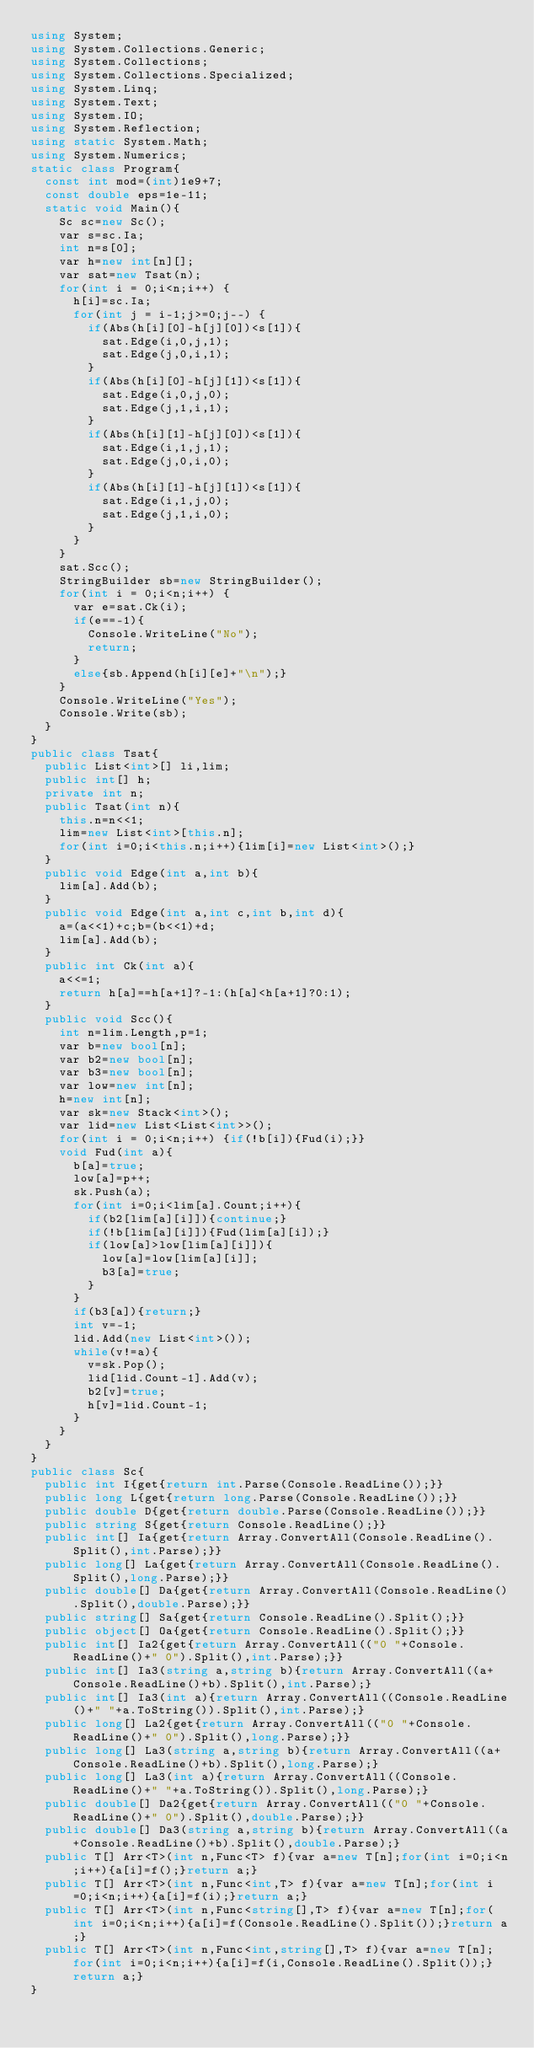Convert code to text. <code><loc_0><loc_0><loc_500><loc_500><_C#_>using System;
using System.Collections.Generic;
using System.Collections;
using System.Collections.Specialized;
using System.Linq;
using System.Text;
using System.IO;
using System.Reflection;
using static System.Math;
using System.Numerics;
static class Program{
	const int mod=(int)1e9+7;
	const double eps=1e-11;
	static void Main(){
		Sc sc=new Sc();
		var s=sc.Ia;
		int n=s[0];
		var h=new int[n][];
		var sat=new Tsat(n);
		for(int i = 0;i<n;i++) {
			h[i]=sc.Ia;
			for(int j = i-1;j>=0;j--) {
				if(Abs(h[i][0]-h[j][0])<s[1]){
					sat.Edge(i,0,j,1);
					sat.Edge(j,0,i,1);
				}
				if(Abs(h[i][0]-h[j][1])<s[1]){
					sat.Edge(i,0,j,0);
					sat.Edge(j,1,i,1);
				}
				if(Abs(h[i][1]-h[j][0])<s[1]){
					sat.Edge(i,1,j,1);
					sat.Edge(j,0,i,0);
				}
				if(Abs(h[i][1]-h[j][1])<s[1]){
					sat.Edge(i,1,j,0);
					sat.Edge(j,1,i,0);
				}
			}
		}
		sat.Scc();
		StringBuilder sb=new StringBuilder();
		for(int i = 0;i<n;i++) {
			var e=sat.Ck(i);
			if(e==-1){
				Console.WriteLine("No");
				return;
			}
			else{sb.Append(h[i][e]+"\n");}
		}
		Console.WriteLine("Yes");
		Console.Write(sb);
	}
}
public class Tsat{
	public List<int>[] li,lim;
	public int[] h;
	private int n;
	public Tsat(int n){
		this.n=n<<1;
		lim=new List<int>[this.n];
		for(int i=0;i<this.n;i++){lim[i]=new List<int>();}
	}
	public void Edge(int a,int b){
		lim[a].Add(b);
	}
	public void Edge(int a,int c,int b,int d){
		a=(a<<1)+c;b=(b<<1)+d;
		lim[a].Add(b);
	}
	public int Ck(int a){
		a<<=1;
		return h[a]==h[a+1]?-1:(h[a]<h[a+1]?0:1);
	}
	public void Scc(){
		int n=lim.Length,p=1;
		var b=new bool[n];
		var b2=new bool[n];
		var b3=new bool[n];
		var low=new int[n];
		h=new int[n];
		var sk=new Stack<int>();
		var lid=new List<List<int>>();
		for(int i = 0;i<n;i++) {if(!b[i]){Fud(i);}}
		void Fud(int a){
			b[a]=true;
			low[a]=p++;
			sk.Push(a);
			for(int i=0;i<lim[a].Count;i++){
				if(b2[lim[a][i]]){continue;}
				if(!b[lim[a][i]]){Fud(lim[a][i]);}
				if(low[a]>low[lim[a][i]]){
					low[a]=low[lim[a][i]];
					b3[a]=true;
				}
			}
			if(b3[a]){return;}
			int v=-1;
			lid.Add(new List<int>());
			while(v!=a){
				v=sk.Pop();
				lid[lid.Count-1].Add(v);
				b2[v]=true;
				h[v]=lid.Count-1;
			}
		}
	}
}
public class Sc{
	public int I{get{return int.Parse(Console.ReadLine());}}
	public long L{get{return long.Parse(Console.ReadLine());}}
	public double D{get{return double.Parse(Console.ReadLine());}}
	public string S{get{return Console.ReadLine();}}
	public int[] Ia{get{return Array.ConvertAll(Console.ReadLine().Split(),int.Parse);}}
	public long[] La{get{return Array.ConvertAll(Console.ReadLine().Split(),long.Parse);}}
	public double[] Da{get{return Array.ConvertAll(Console.ReadLine().Split(),double.Parse);}}
	public string[] Sa{get{return Console.ReadLine().Split();}}
	public object[] Oa{get{return Console.ReadLine().Split();}}
	public int[] Ia2{get{return Array.ConvertAll(("0 "+Console.ReadLine()+" 0").Split(),int.Parse);}}
	public int[] Ia3(string a,string b){return Array.ConvertAll((a+Console.ReadLine()+b).Split(),int.Parse);}
	public int[] Ia3(int a){return Array.ConvertAll((Console.ReadLine()+" "+a.ToString()).Split(),int.Parse);}
	public long[] La2{get{return Array.ConvertAll(("0 "+Console.ReadLine()+" 0").Split(),long.Parse);}}
	public long[] La3(string a,string b){return Array.ConvertAll((a+Console.ReadLine()+b).Split(),long.Parse);}
	public long[] La3(int a){return Array.ConvertAll((Console.ReadLine()+" "+a.ToString()).Split(),long.Parse);}
	public double[] Da2{get{return Array.ConvertAll(("0 "+Console.ReadLine()+" 0").Split(),double.Parse);}}
	public double[] Da3(string a,string b){return Array.ConvertAll((a+Console.ReadLine()+b).Split(),double.Parse);}
	public T[] Arr<T>(int n,Func<T> f){var a=new T[n];for(int i=0;i<n;i++){a[i]=f();}return a;}
	public T[] Arr<T>(int n,Func<int,T> f){var a=new T[n];for(int i=0;i<n;i++){a[i]=f(i);}return a;}
	public T[] Arr<T>(int n,Func<string[],T> f){var a=new T[n];for(int i=0;i<n;i++){a[i]=f(Console.ReadLine().Split());}return a;}
	public T[] Arr<T>(int n,Func<int,string[],T> f){var a=new T[n];for(int i=0;i<n;i++){a[i]=f(i,Console.ReadLine().Split());}return a;}
}</code> 